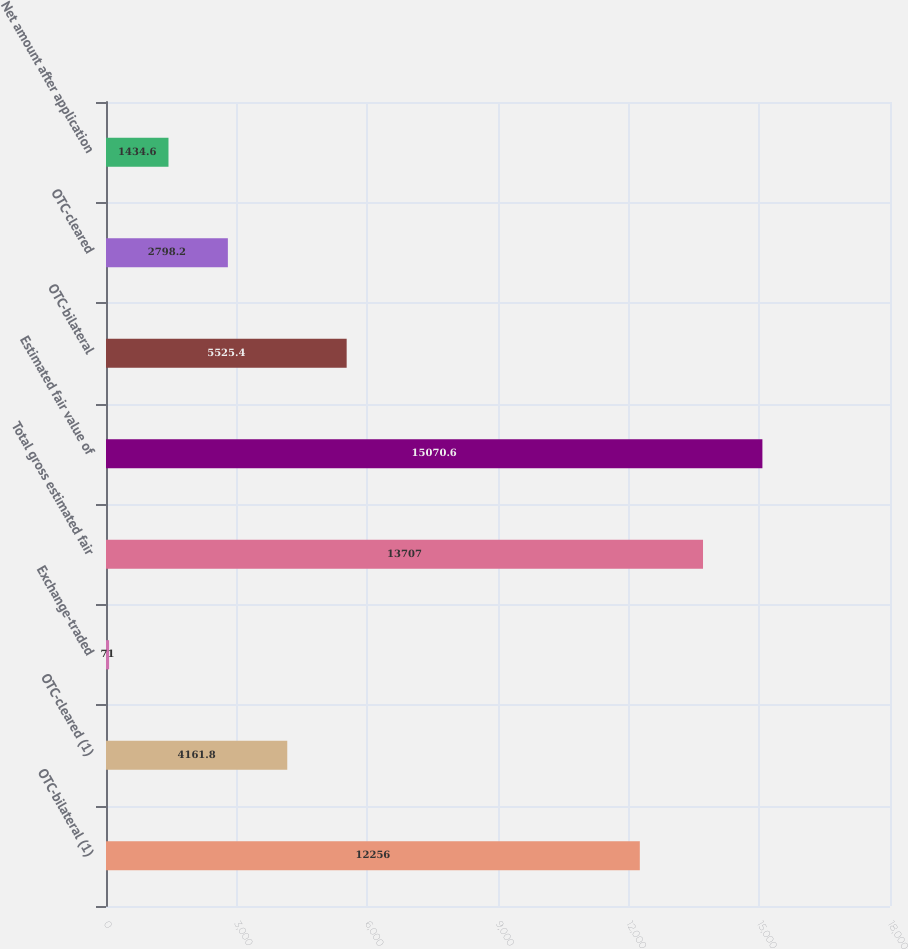Convert chart to OTSL. <chart><loc_0><loc_0><loc_500><loc_500><bar_chart><fcel>OTC-bilateral (1)<fcel>OTC-cleared (1)<fcel>Exchange-traded<fcel>Total gross estimated fair<fcel>Estimated fair value of<fcel>OTC-bilateral<fcel>OTC-cleared<fcel>Net amount after application<nl><fcel>12256<fcel>4161.8<fcel>71<fcel>13707<fcel>15070.6<fcel>5525.4<fcel>2798.2<fcel>1434.6<nl></chart> 